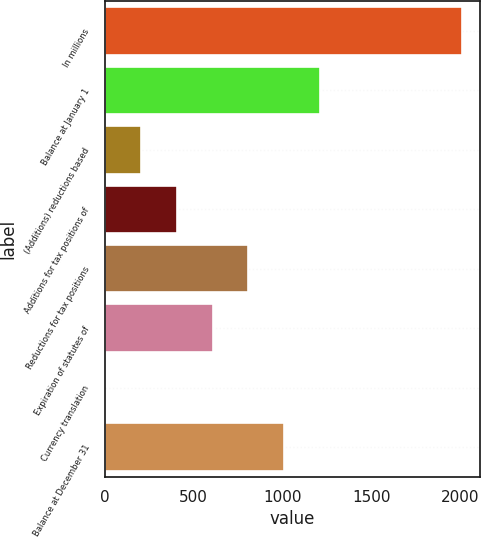<chart> <loc_0><loc_0><loc_500><loc_500><bar_chart><fcel>In millions<fcel>Balance at January 1<fcel>(Additions) reductions based<fcel>Additions for tax positions of<fcel>Reductions for tax positions<fcel>Expiration of statutes of<fcel>Currency translation<fcel>Balance at December 31<nl><fcel>2010<fcel>1207.6<fcel>204.6<fcel>405.2<fcel>806.4<fcel>605.8<fcel>4<fcel>1007<nl></chart> 